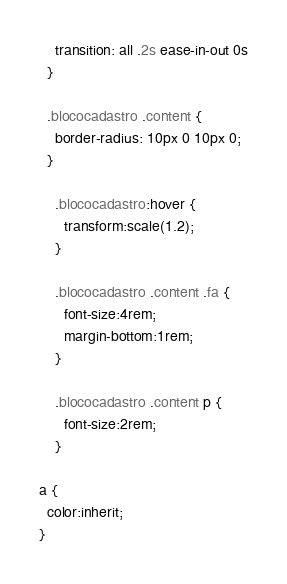<code> <loc_0><loc_0><loc_500><loc_500><_CSS_>    transition: all .2s ease-in-out 0s
  }

  .blococadastro .content {
    border-radius: 10px 0 10px 0;
  }

    .blococadastro:hover {
      transform:scale(1.2);
    }

    .blococadastro .content .fa {
      font-size:4rem;
      margin-bottom:1rem;
    }

    .blococadastro .content p {
      font-size:2rem;
    }

a {
  color:inherit;
}</code> 